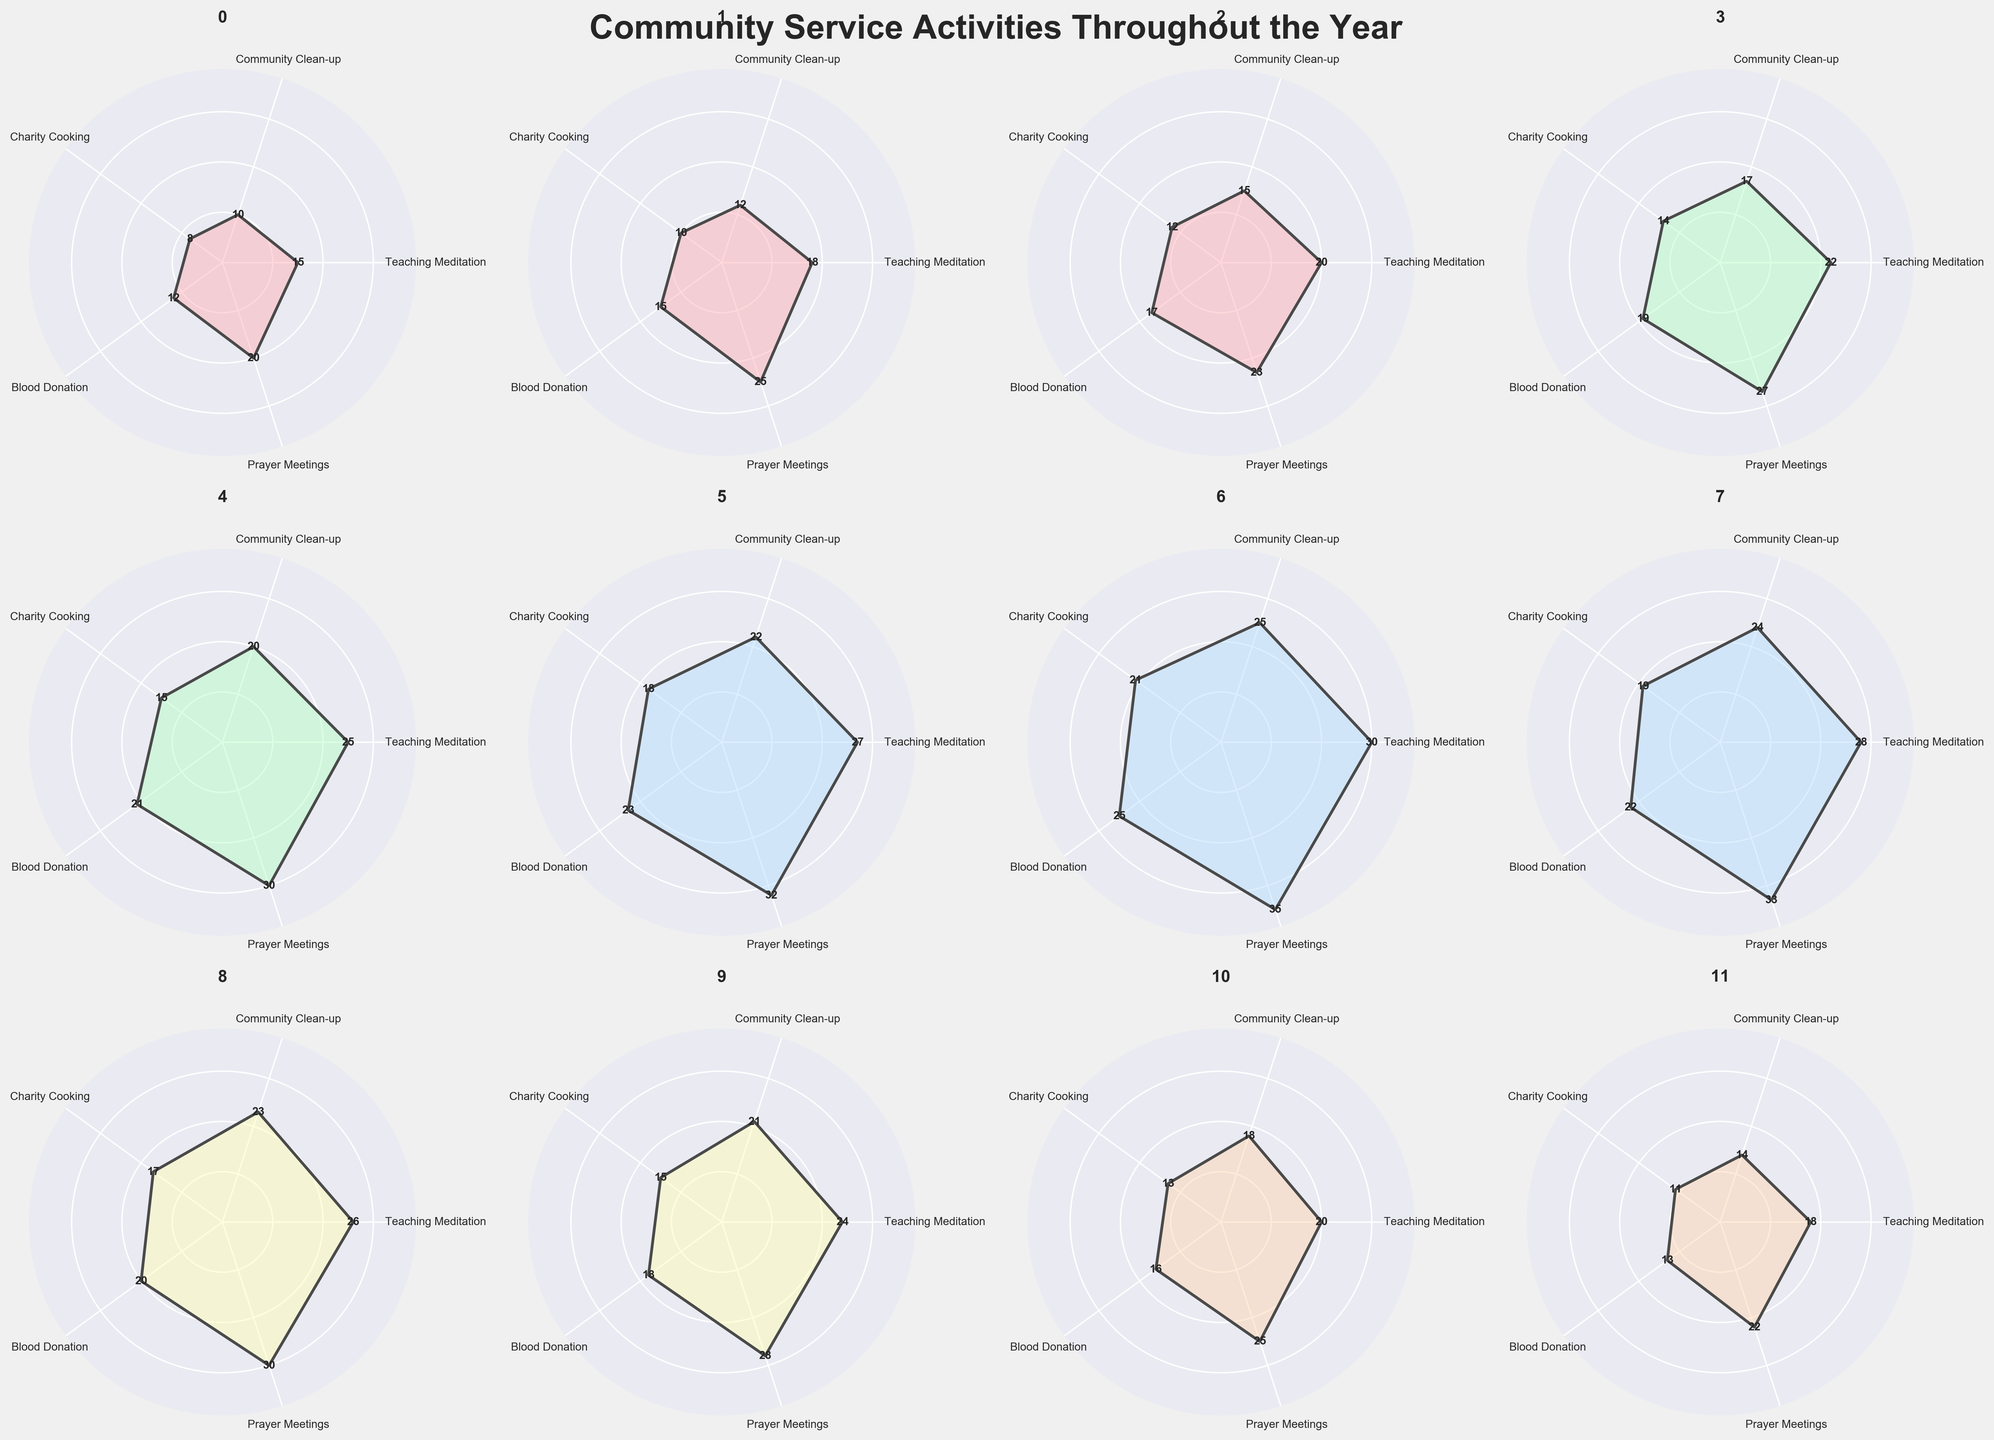what is the title of the figure? The title is a text prominently displayed at the top of the figure. It summarizes the overall subject of the data being visualized. The title for this figure is "Community Service Activities Throughout the Year."
Answer: Community Service Activities Throughout the Year Which month has the highest participation in Prayer Meetings? By examining the rose charts for each month, you can identify the one with the highest radial length for Prayer Meetings (represented specifically in this segment for each month). July has the highest participation in Prayer Meetings with a value of 35.
Answer: July Between February and June, in which month did Charity Cooking see the greatest increase in participation? To determine this, check the values for Charity Cooking in February and June. The value in February is 10, and in June, it is 18. The greatest increase in participation is between February and June.
Answer: June What is the average participation rate for Community Clean-up activities from January to March? To find the average, sum the participation rates for January, February, and March and divide by 3. The sum of the rates is 10 + 12 + 15 = 37. The average rate is 37 / 3 = 12.33.
Answer: 12.33 Which activity has the smallest difference between its highest and lowest monthly participation? Calculate the difference between the highest and lowest participation for each activity by checking the extremes in the radial charts. The differences are: Teaching Meditation (30-15=15), Community Clean-up (25-10=15), Charity Cooking (21-8=13), Blood Donation (25-12=13), and Prayer Meetings (35-20=15). Charity Cooking and Blood Donation both have the smallest difference of 13.
Answer: Charity Cooking and Blood Donation In which months does Blood Donation participation meet or exceed 20? Examine the radial charts for Blood Donation and identify months where the participation rate is 20 or more. These months are March, April, May, June, July, August, and September.
Answer: March, April, May, June, July, August, September Which activity shows a consistent increase in participation every month from January to July? Assess each radial chart for a consistent increase in values from January to July. Teaching Meditation, Community Clean-up, Charity Cooking, Blood Donation, and Prayer Meetings all show consistent increases in those months.
Answer: All activities What is the total participation in Community Clean-up activities from April to August? Sum the participation rates for Community Clean-up from April through August. The values are 17, 20, 22, 25, and 24. The sum is 17 + 20 + 22 + 25 + 24 = 108.
Answer: 108 Which activity has the most fluctuation in participation over the year? The activity with the most fluctuation will have the largest range (difference between maximum and minimum values). Calculate the range for each activity: Teaching Meditation (30-15=15), Community Clean-up (25-10=15), Charity Cooking (21-8=13), Blood Donation (25-12=13), and Prayer Meetings (35-20=15). Teaching Meditation, Community Clean-up, and Prayer Meetings have the highest fluctuation of 15.
Answer: Teaching Meditation, Community Clean-up, and Prayer Meetings Which two consecutive months show the largest increase in average participation across all activities? Calculate the average participation for each month and find the consecutive months with the largest increase. For example:
- January: (15+10+8+12+20)=65, average=13
- February: (18+12+10+15+25)=80, average=16
- Increase: 16-13=3
Perform this for all months, and find the largest increase between consecutive averages. The largest increase is from May (average 22.2) to June (average 24.4), an increase of 2.2.
Answer: May to June 